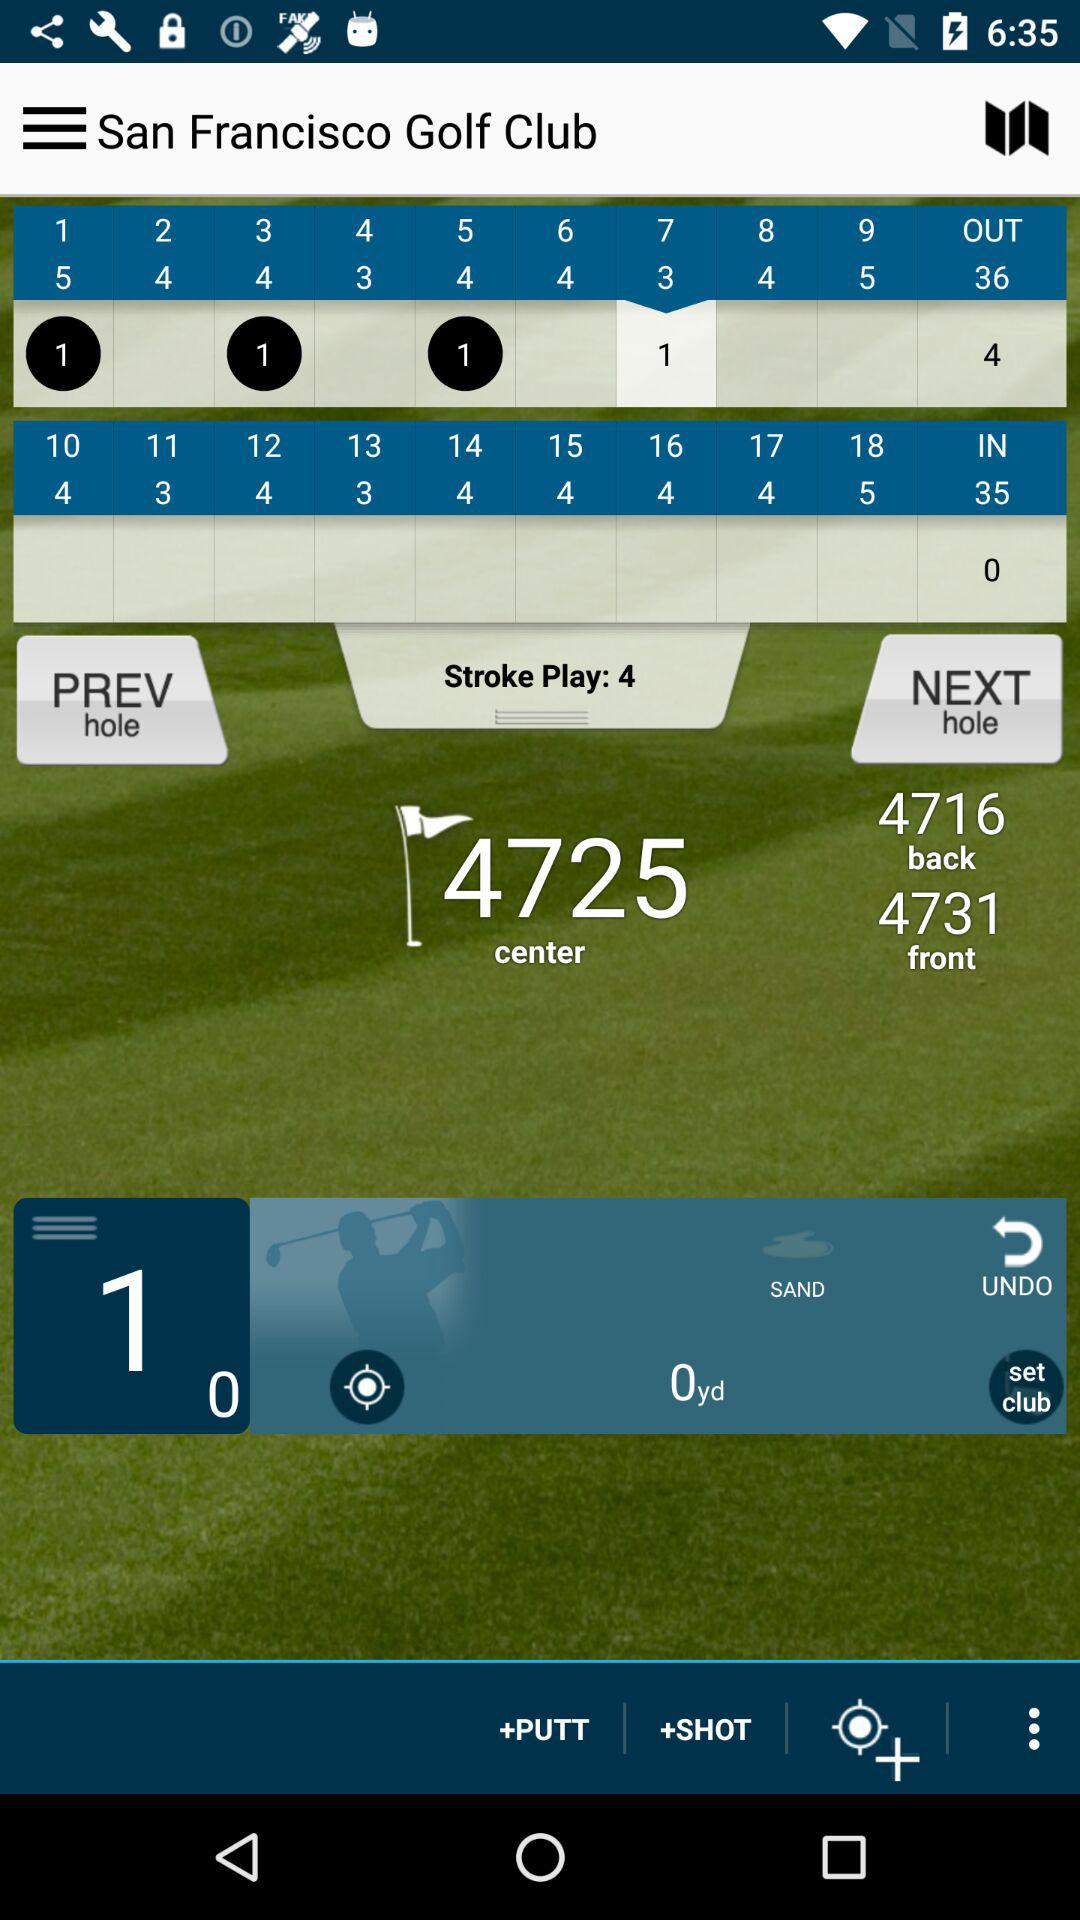How much is the stroke play? The stroke play is 4. 